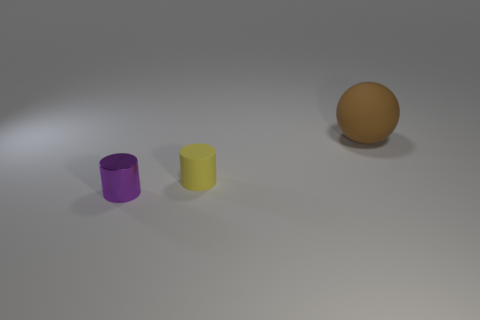Are there any purple cylinders in front of the brown sphere? Yes, there is one purple cylinder situated in front of the brown sphere, resting on the same flat surface. 